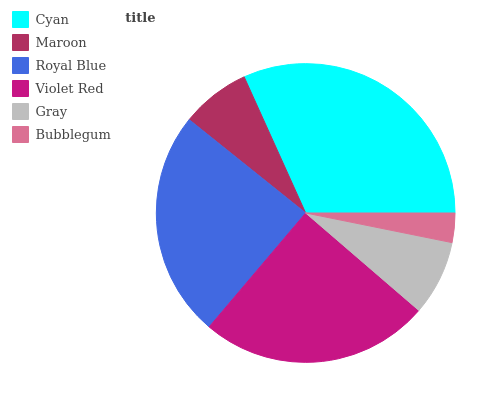Is Bubblegum the minimum?
Answer yes or no. Yes. Is Cyan the maximum?
Answer yes or no. Yes. Is Maroon the minimum?
Answer yes or no. No. Is Maroon the maximum?
Answer yes or no. No. Is Cyan greater than Maroon?
Answer yes or no. Yes. Is Maroon less than Cyan?
Answer yes or no. Yes. Is Maroon greater than Cyan?
Answer yes or no. No. Is Cyan less than Maroon?
Answer yes or no. No. Is Royal Blue the high median?
Answer yes or no. Yes. Is Gray the low median?
Answer yes or no. Yes. Is Violet Red the high median?
Answer yes or no. No. Is Bubblegum the low median?
Answer yes or no. No. 